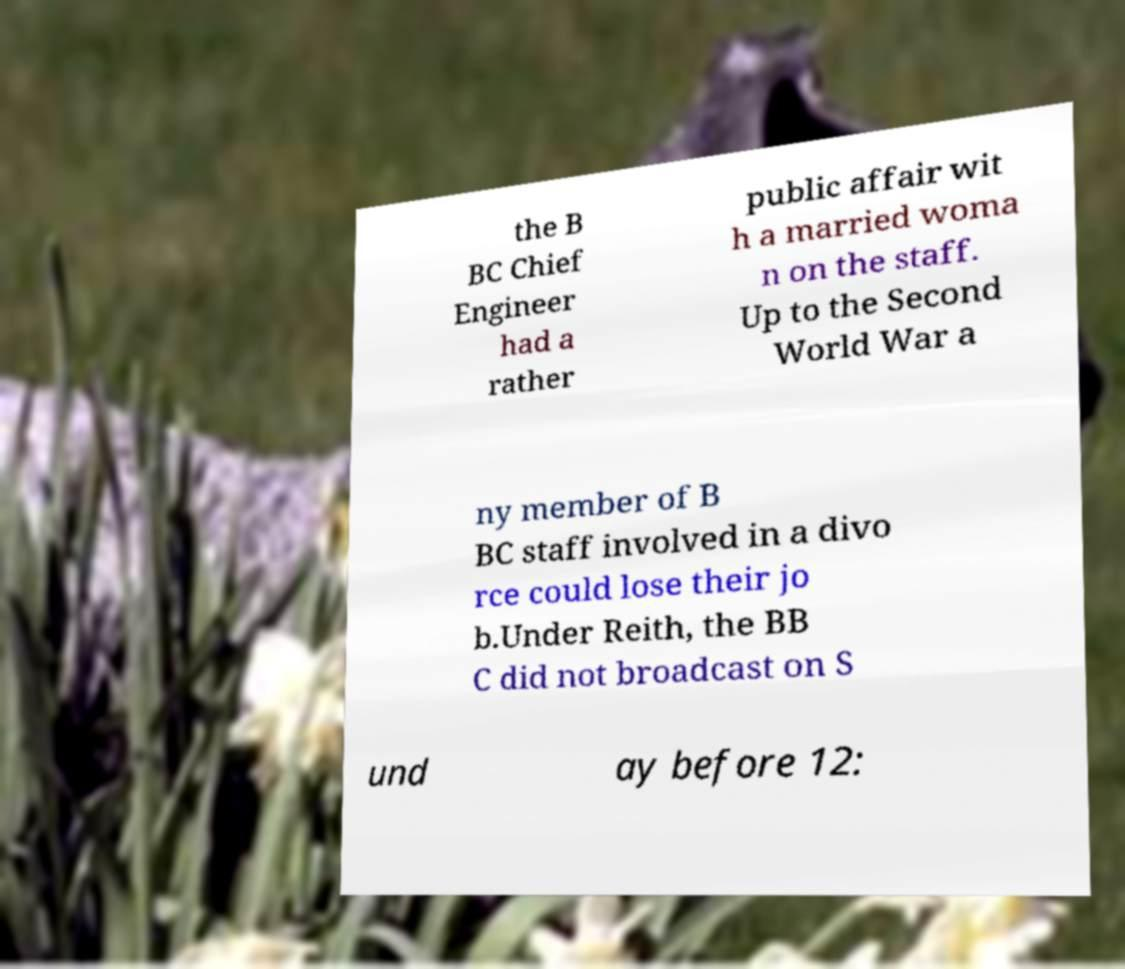Can you accurately transcribe the text from the provided image for me? the B BC Chief Engineer had a rather public affair wit h a married woma n on the staff. Up to the Second World War a ny member of B BC staff involved in a divo rce could lose their jo b.Under Reith, the BB C did not broadcast on S und ay before 12: 